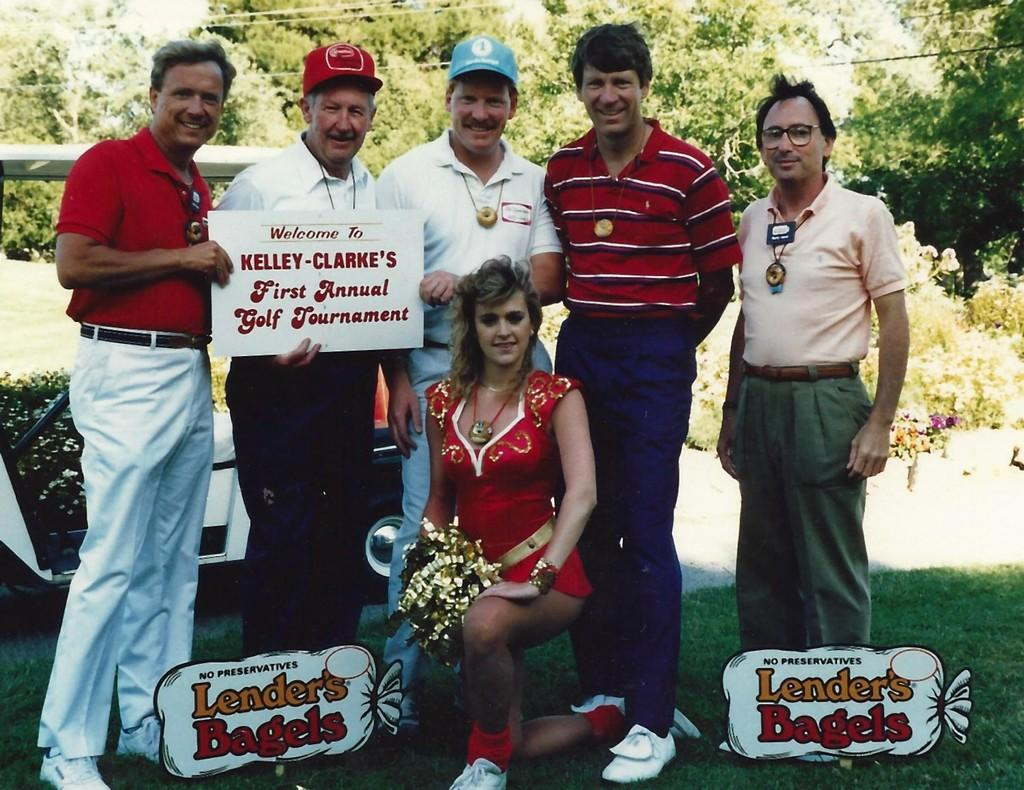How many persons are in the image? There are persons in the image. What are the persons holding in the image? The persons are holding a board with their hands. What type of terrain is visible in the image? There is grass in the image. What other types of vegetation can be seen in the image? There are plants in the image. What type of man-made object is present in the image? There is a vehicle in the image. What can be seen in the background of the image? There are trees in the background of the image. What type of bedroom furniture can be seen in the image? There is no bedroom furniture present in the image. What causes the tramp to burst in the image? There is no tramp present in the image, so it cannot burst. 